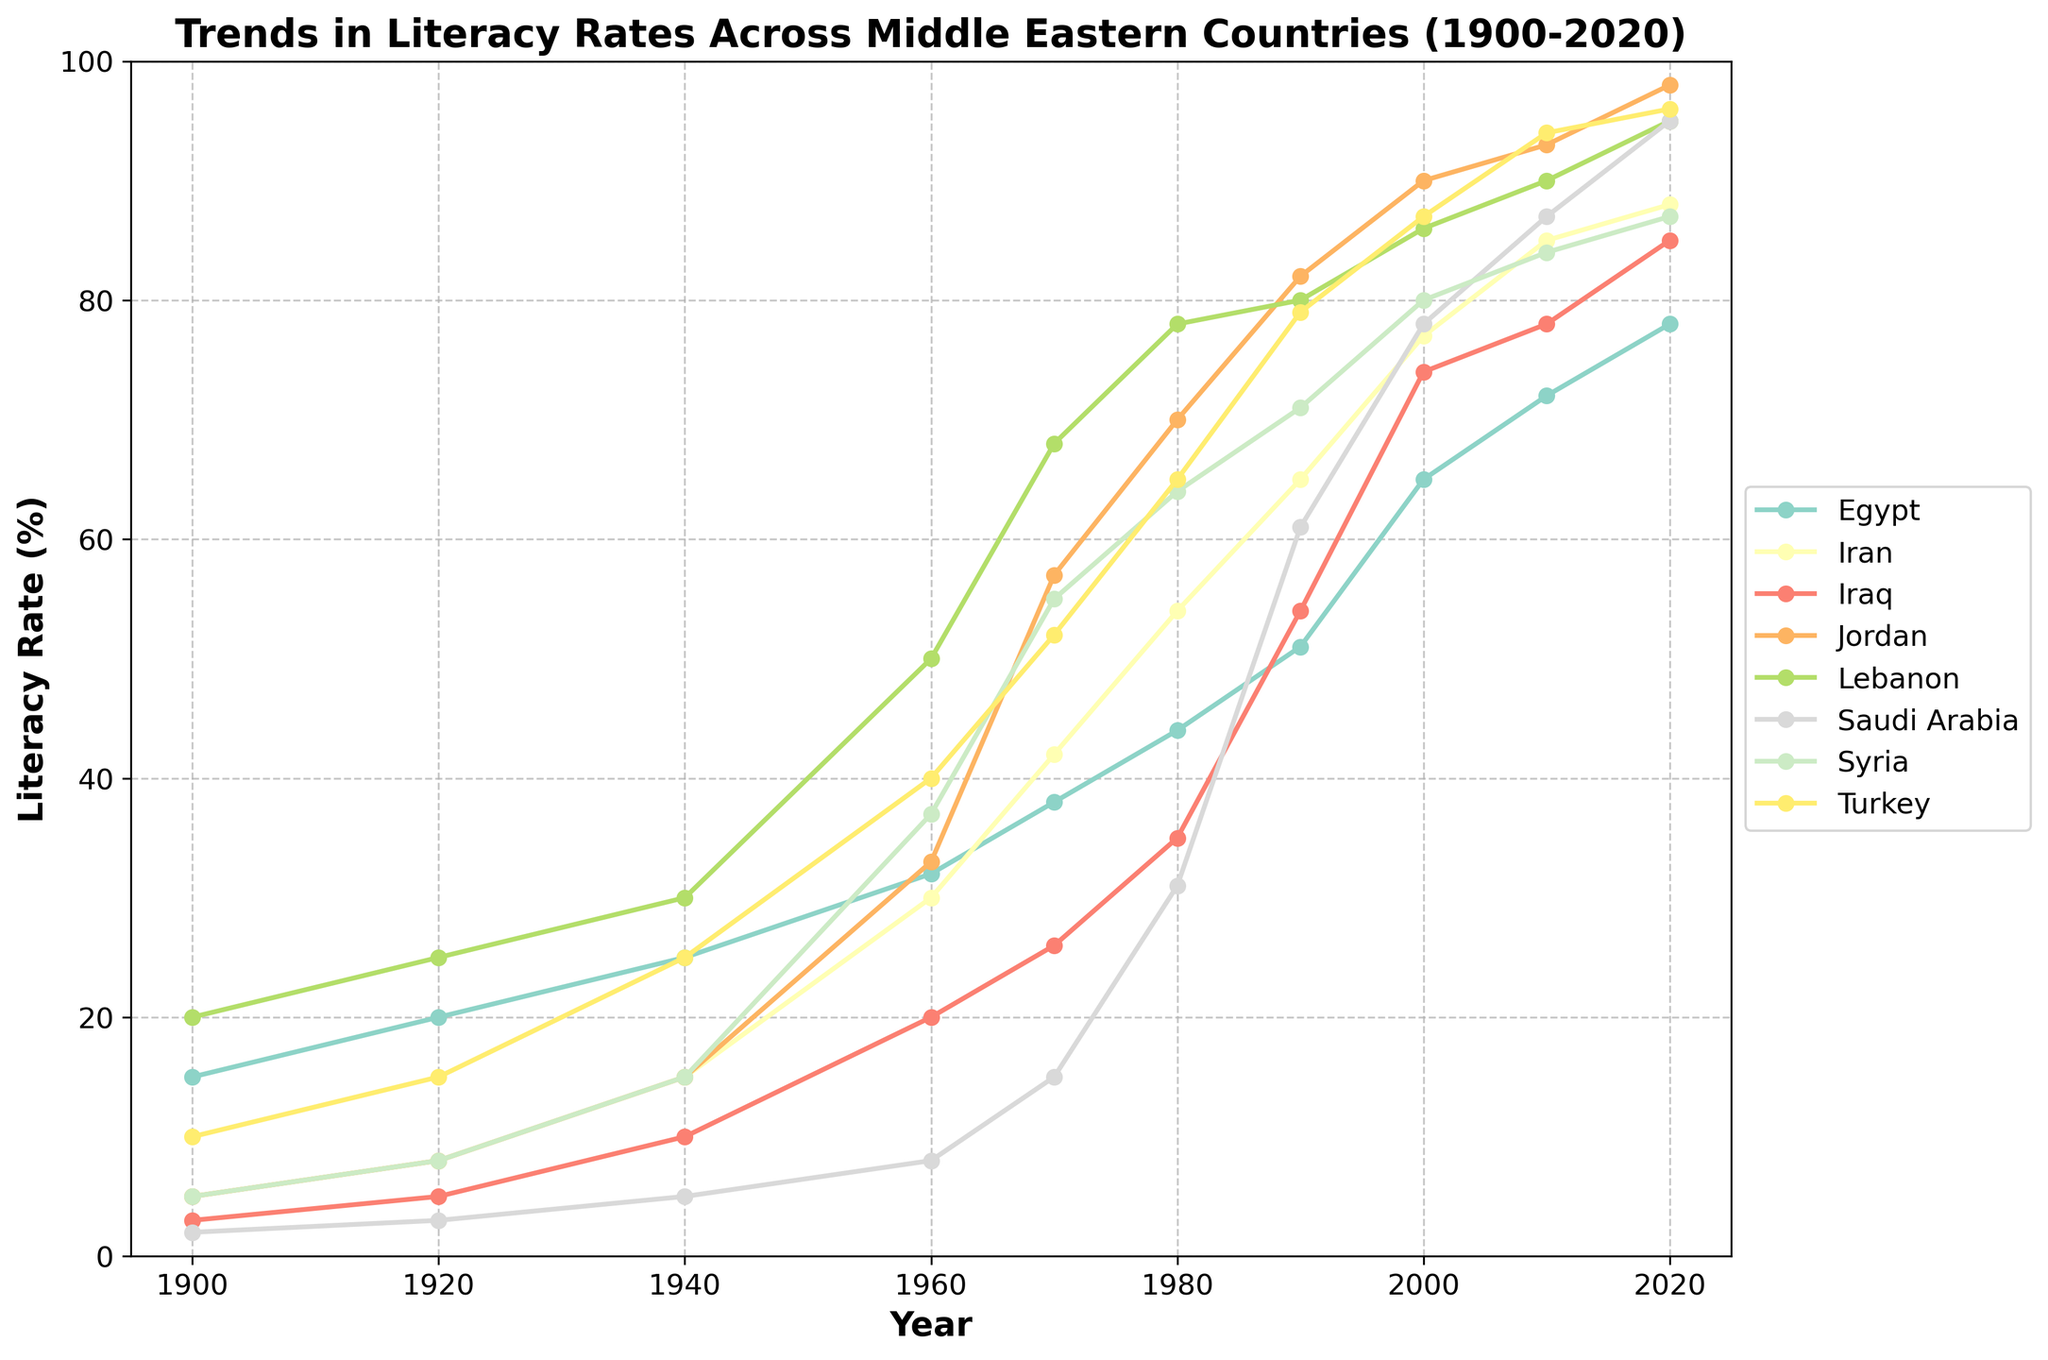Which country had the lowest literacy rate in 1900? Observe the plotted lines at the year 1900. The line representing Saudi Arabia is at the bottom with a literacy rate of around 2%.
Answer: Saudi Arabia Which country shows the highest increase in literacy rate from 1900 to 2020? Calculate the difference between the literacy rates of 2020 and 1900 for each country and compare. Saudi Arabia increased from 2% to 95%, a rise of 93%.
Answer: Saudi Arabia In which decade did Jordan surpass Egypt in literacy rate? Look at the plotted lines and observe where Jordan's line crosses above Egypt’s line. This happens between 1960 and 1970.
Answer: 1960s What is the average literacy rate of Lebanon in the recorded data? Sum up all Lebanon's literacy rates and divide by the number of data points: (20 + 25 + 30 + 50 + 68 + 78 + 80 + 86 + 90 + 95)/10 = 62.2%
Answer: 62.2% Which countries had a literacy rate higher than 80% in 2010? Examine the plotted lines for 2010 and identify those above the 80% mark. Iran, Iraq, Jordan, Lebanon, and Turkey exceed 80%.
Answer: Iran, Iraq, Jordan, Lebanon, Turkey What trend can be seen for Syria's literacy rate between 1960 and 1980? Observe the line for Syria between 1960 and 1980; it shows an upward trend from around 37% to 64%.
Answer: It steadily increased How does the literacy rate growth of Egypt between 1900 and 2000 compare to that of Turkey? Calculate the increase for both: Egypt (65% - 15% = 50%) and Turkey (87% - 10% = 77%). Turkey's increase is larger.
Answer: Turkey's increase is larger Which country's literacy rate was closest to the average rate of all countries in 1940? Calculate the average rate in 1940: (25+15+10+15+30+5+15+25)/8 ≈ 17.5%. Compare each country’s rate to this average. Iraq (10%) is closest.
Answer: Iraq What was the difference in literacy rate between Iran and Saudi Arabia in 1990? Find the rates of both countries in 1990 and subtract: Iran (65%) and Saudi Arabia (61%), the difference is 4%.
Answer: 4% Which country has consistently shown an increasing trend in literacy rates over the entire period? Identify countries whose lines continuously go upward without any dips from 1900 to 2020. Iran shows a consistent upward trend.
Answer: Iran 